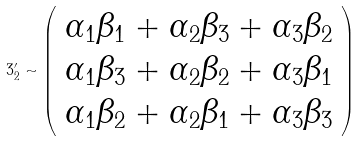<formula> <loc_0><loc_0><loc_500><loc_500>3 ^ { \prime } _ { 2 } \sim \left ( \begin{array} { c } \alpha _ { 1 } \beta _ { 1 } + \alpha _ { 2 } \beta _ { 3 } + \alpha _ { 3 } \beta _ { 2 } \\ \alpha _ { 1 } \beta _ { 3 } + \alpha _ { 2 } \beta _ { 2 } + \alpha _ { 3 } \beta _ { 1 } \\ \alpha _ { 1 } \beta _ { 2 } + \alpha _ { 2 } \beta _ { 1 } + \alpha _ { 3 } \beta _ { 3 } \end{array} \right )</formula> 